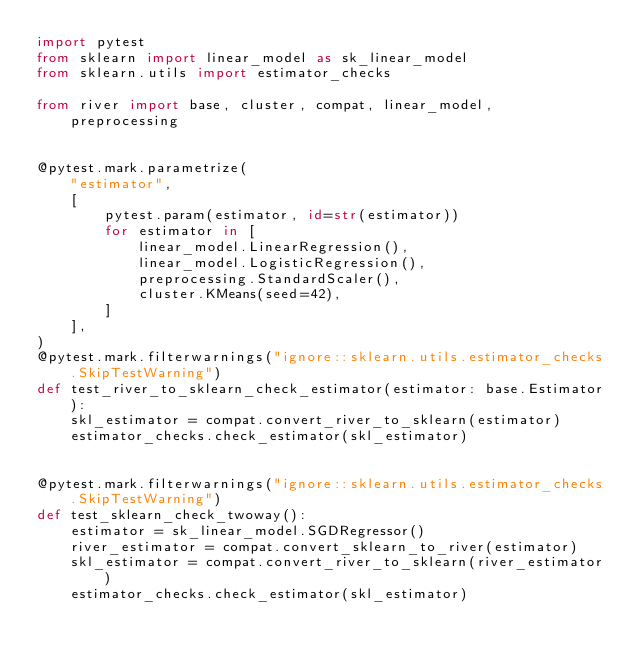Convert code to text. <code><loc_0><loc_0><loc_500><loc_500><_Python_>import pytest
from sklearn import linear_model as sk_linear_model
from sklearn.utils import estimator_checks

from river import base, cluster, compat, linear_model, preprocessing


@pytest.mark.parametrize(
    "estimator",
    [
        pytest.param(estimator, id=str(estimator))
        for estimator in [
            linear_model.LinearRegression(),
            linear_model.LogisticRegression(),
            preprocessing.StandardScaler(),
            cluster.KMeans(seed=42),
        ]
    ],
)
@pytest.mark.filterwarnings("ignore::sklearn.utils.estimator_checks.SkipTestWarning")
def test_river_to_sklearn_check_estimator(estimator: base.Estimator):
    skl_estimator = compat.convert_river_to_sklearn(estimator)
    estimator_checks.check_estimator(skl_estimator)


@pytest.mark.filterwarnings("ignore::sklearn.utils.estimator_checks.SkipTestWarning")
def test_sklearn_check_twoway():
    estimator = sk_linear_model.SGDRegressor()
    river_estimator = compat.convert_sklearn_to_river(estimator)
    skl_estimator = compat.convert_river_to_sklearn(river_estimator)
    estimator_checks.check_estimator(skl_estimator)
</code> 